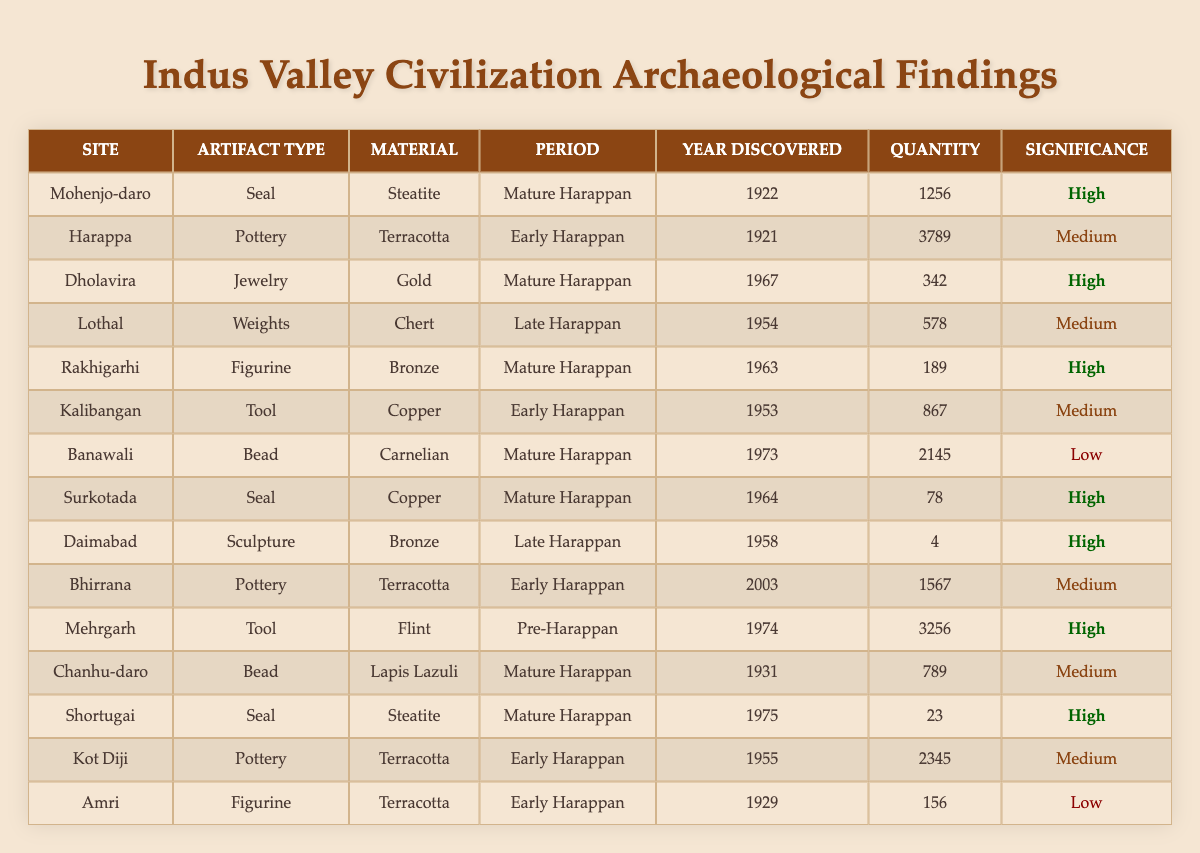What is the total quantity of artifacts discovered at Mohenjo-daro? The table shows that Mohenjo-daro has a quantity of 1256 artifacts. Therefore, the total quantity of artifacts discovered at Mohenjo-daro is 1256.
Answer: 1256 Which site had the highest quantity of pottery artifacts? Referring to the table, Harappa has the highest quantity of pottery artifacts with a total of 3789.
Answer: Harappa How many artifacts of significance "Low" were discovered? There are two artifacts with "Low" significance: one from Banawali with 2145 beads and one from Amri with 156 figurines. Combining these quantities gives 2145 + 156 = 2301.
Answer: 2301 Is there any artifact discovered in the year 1964? Looking at the table, there is an artifact from Surkotada that was discovered in the year 1964, indicating that the statement is true.
Answer: Yes What is the period with the most artifacts showing high significance? Analyzing the table shows that the Mature Harappan period has four artifacts with high significance (Mohenjo-daro, Dholavira, Rakhigarhi, and Surkotada). Thus, the period with the most high-significance artifacts is Mature Harappan.
Answer: Mature Harappan What is the average quantity of artifacts discovered in the Early Harappan period? In the Early Harappan period, the artifacts quantity are from Harappa (3789), Kalibangan (867), Bhirrana (1567), and Kot Diji (2345). Summing these gives 3789 + 867 + 1567 + 2345 = 8780. Since there are 4 artifacts, the average quantity is 8780 / 4 = 2195.
Answer: 2195 Which material has the least quantity of artifacts? Analyzing the table shows that the material with the least quantity of artifacts is Bronze, with the artifact from Daimabad having only 4 sculptures. Thus, Bronze has the least quantity.
Answer: Bronze What significant materials were used for artifacts in the Late Harappan period? Referring to the table, the materials used in the Late Harappan period are Bronze (Daimabad) and Chert (Lothal), indicating two materials were significant during this period.
Answer: Bronze and Chert How many figurines were discovered in total? The table identifies two figurines, one from Rakhigarhi (189) and one from Amri (156). The total quantity of figurines is 189 + 156 = 345.
Answer: 345 